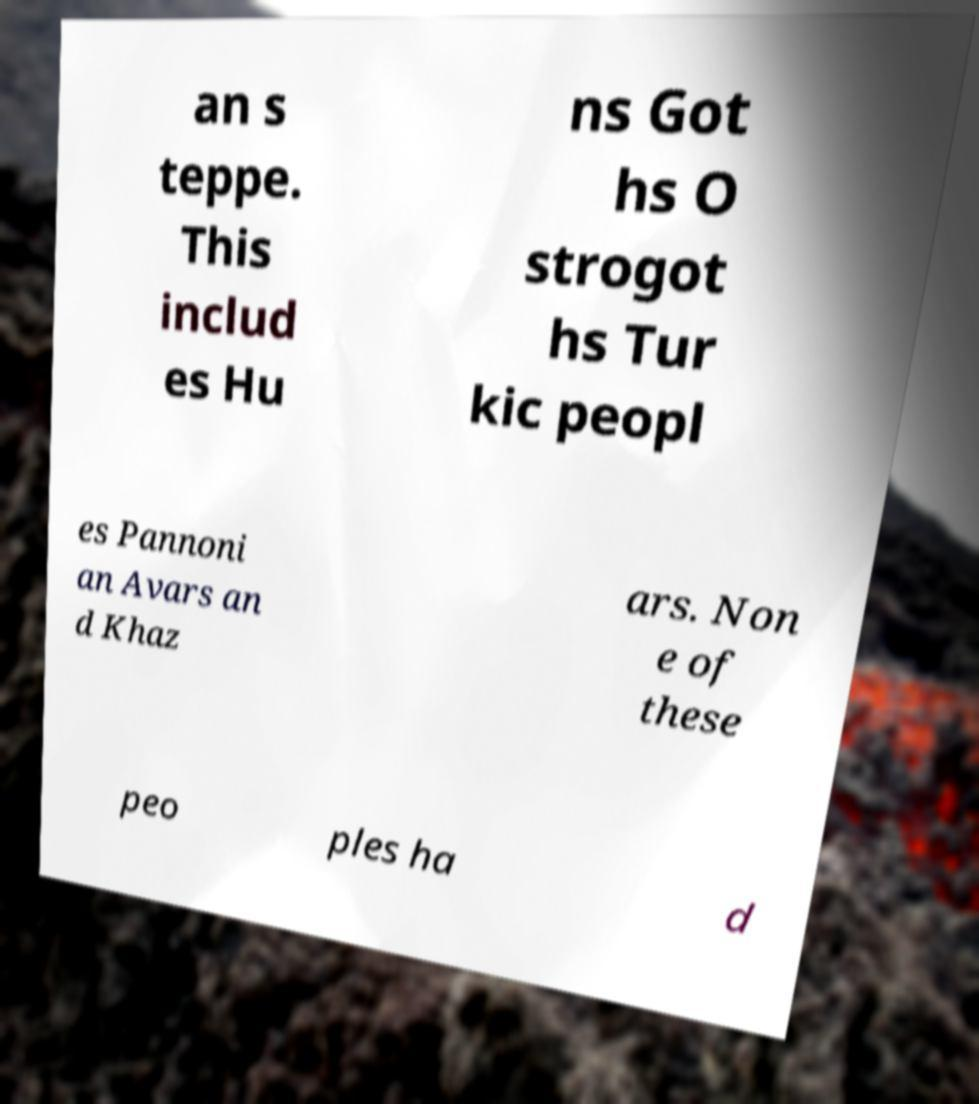Can you read and provide the text displayed in the image?This photo seems to have some interesting text. Can you extract and type it out for me? an s teppe. This includ es Hu ns Got hs O strogot hs Tur kic peopl es Pannoni an Avars an d Khaz ars. Non e of these peo ples ha d 